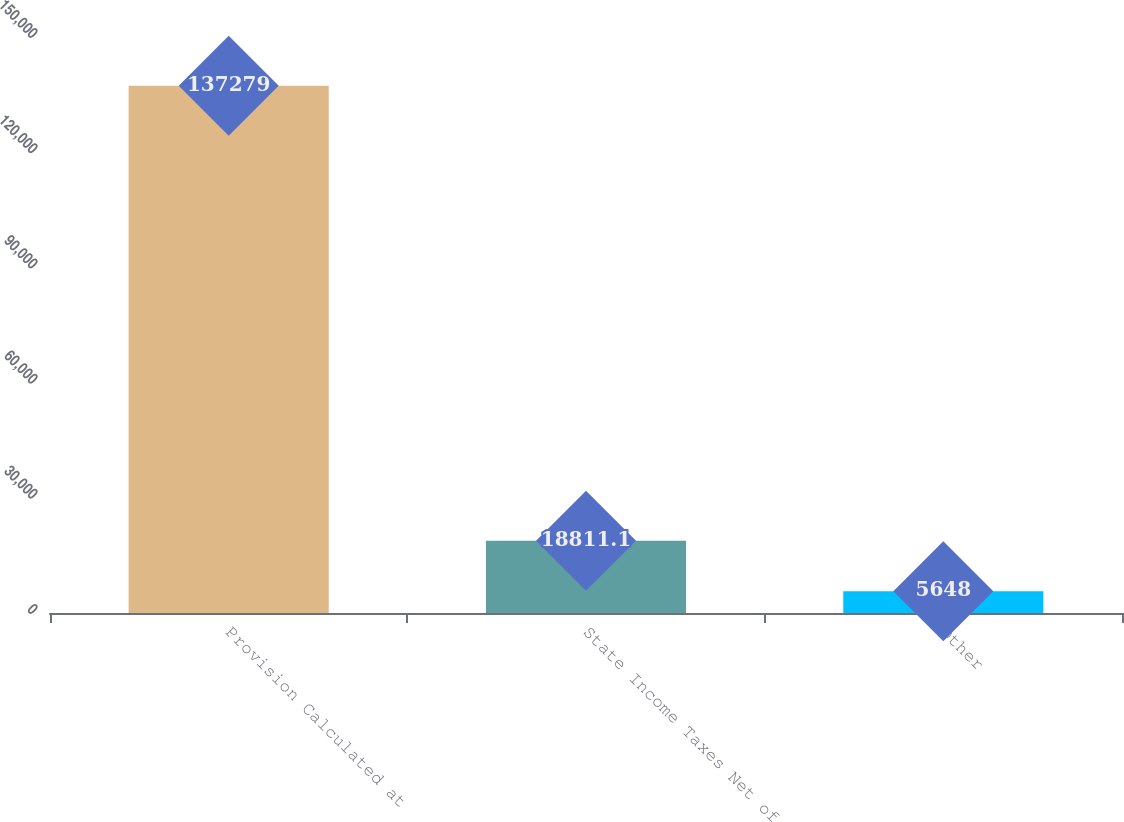<chart> <loc_0><loc_0><loc_500><loc_500><bar_chart><fcel>Provision Calculated at<fcel>State Income Taxes Net of<fcel>Other<nl><fcel>137279<fcel>18811.1<fcel>5648<nl></chart> 